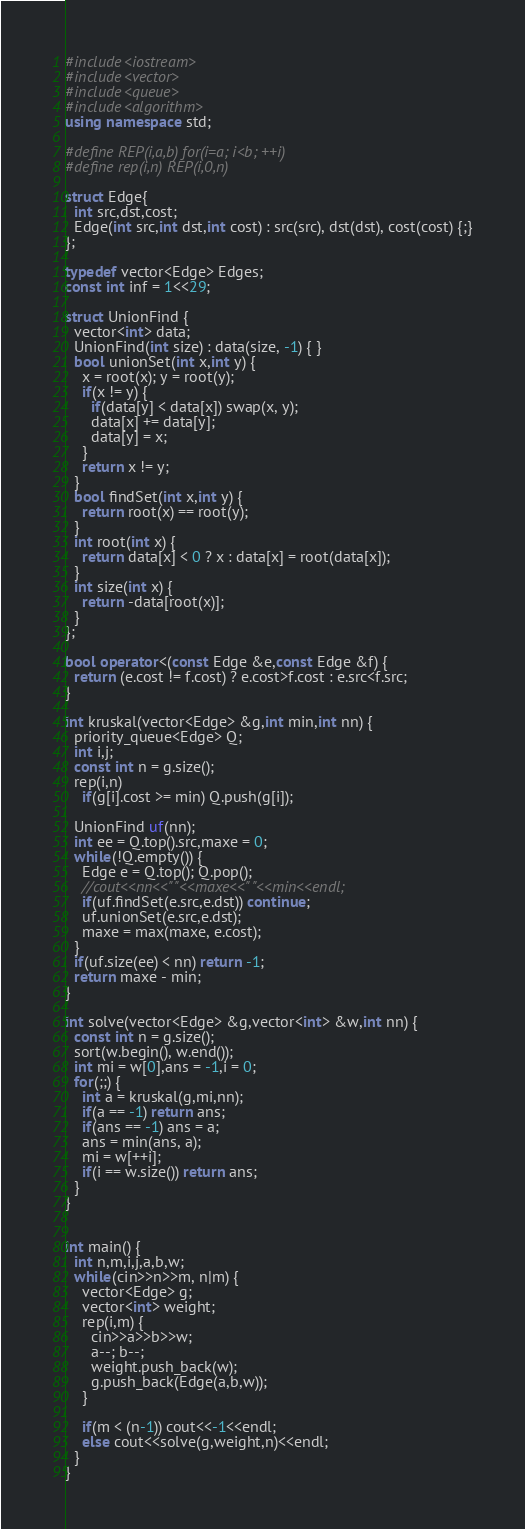Convert code to text. <code><loc_0><loc_0><loc_500><loc_500><_C++_>#include<iostream>
#include<vector>
#include<queue>
#include<algorithm>
using namespace std;

#define REP(i,a,b) for(i=a; i<b; ++i)
#define rep(i,n) REP(i,0,n)

struct Edge{
  int src,dst,cost;
  Edge(int src,int dst,int cost) : src(src), dst(dst), cost(cost) {;}
};

typedef vector<Edge> Edges;
const int inf = 1<<29;

struct UnionFind {
  vector<int> data;
  UnionFind(int size) : data(size, -1) { }
  bool unionSet(int x,int y) {
    x = root(x); y = root(y);
    if(x != y) {
      if(data[y] < data[x]) swap(x, y);
      data[x] += data[y];
      data[y] = x;
    }
    return x != y;
  }
  bool findSet(int x,int y) {
    return root(x) == root(y);
  }
  int root(int x) {
    return data[x] < 0 ? x : data[x] = root(data[x]);
  }
  int size(int x) {
    return -data[root(x)];
  }
};

bool operator<(const Edge &e,const Edge &f) {
  return (e.cost != f.cost) ? e.cost>f.cost : e.src<f.src;
}

int kruskal(vector<Edge> &g,int min,int nn) {
  priority_queue<Edge> Q;
  int i,j;
  const int n = g.size();
  rep(i,n)
    if(g[i].cost >= min) Q.push(g[i]);

  UnionFind uf(nn);
  int ee = Q.top().src,maxe = 0;
  while(!Q.empty()) {
    Edge e = Q.top(); Q.pop();
    //cout<<nn<<" "<<maxe<<" "<<min<<endl;
    if(uf.findSet(e.src,e.dst)) continue;
    uf.unionSet(e.src,e.dst);
    maxe = max(maxe, e.cost);
  }
  if(uf.size(ee) < nn) return -1;
  return maxe - min;
}

int solve(vector<Edge> &g,vector<int> &w,int nn) {
  const int n = g.size();
  sort(w.begin(), w.end());
  int mi = w[0],ans = -1,i = 0;
  for(;;) {
    int a = kruskal(g,mi,nn);
    if(a == -1) return ans;
    if(ans == -1) ans = a;
    ans = min(ans, a);
    mi = w[++i];
    if(i == w.size()) return ans;
  }
}


int main() {
  int n,m,i,j,a,b,w;
  while(cin>>n>>m, n|m) {
    vector<Edge> g;
    vector<int> weight;
    rep(i,m) {
      cin>>a>>b>>w;
      a--; b--;
      weight.push_back(w);
      g.push_back(Edge(a,b,w));
    }

    if(m < (n-1)) cout<<-1<<endl;
    else cout<<solve(g,weight,n)<<endl;
  }
}</code> 